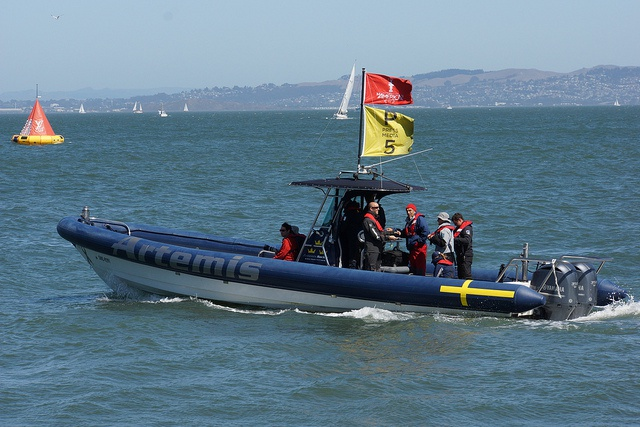Describe the objects in this image and their specific colors. I can see boat in lightblue, black, gray, navy, and blue tones, people in lightblue, black, navy, gray, and brown tones, people in lightblue, black, gray, maroon, and salmon tones, people in lightblue, black, gray, and maroon tones, and people in lightblue, black, lightgray, darkgray, and gray tones in this image. 